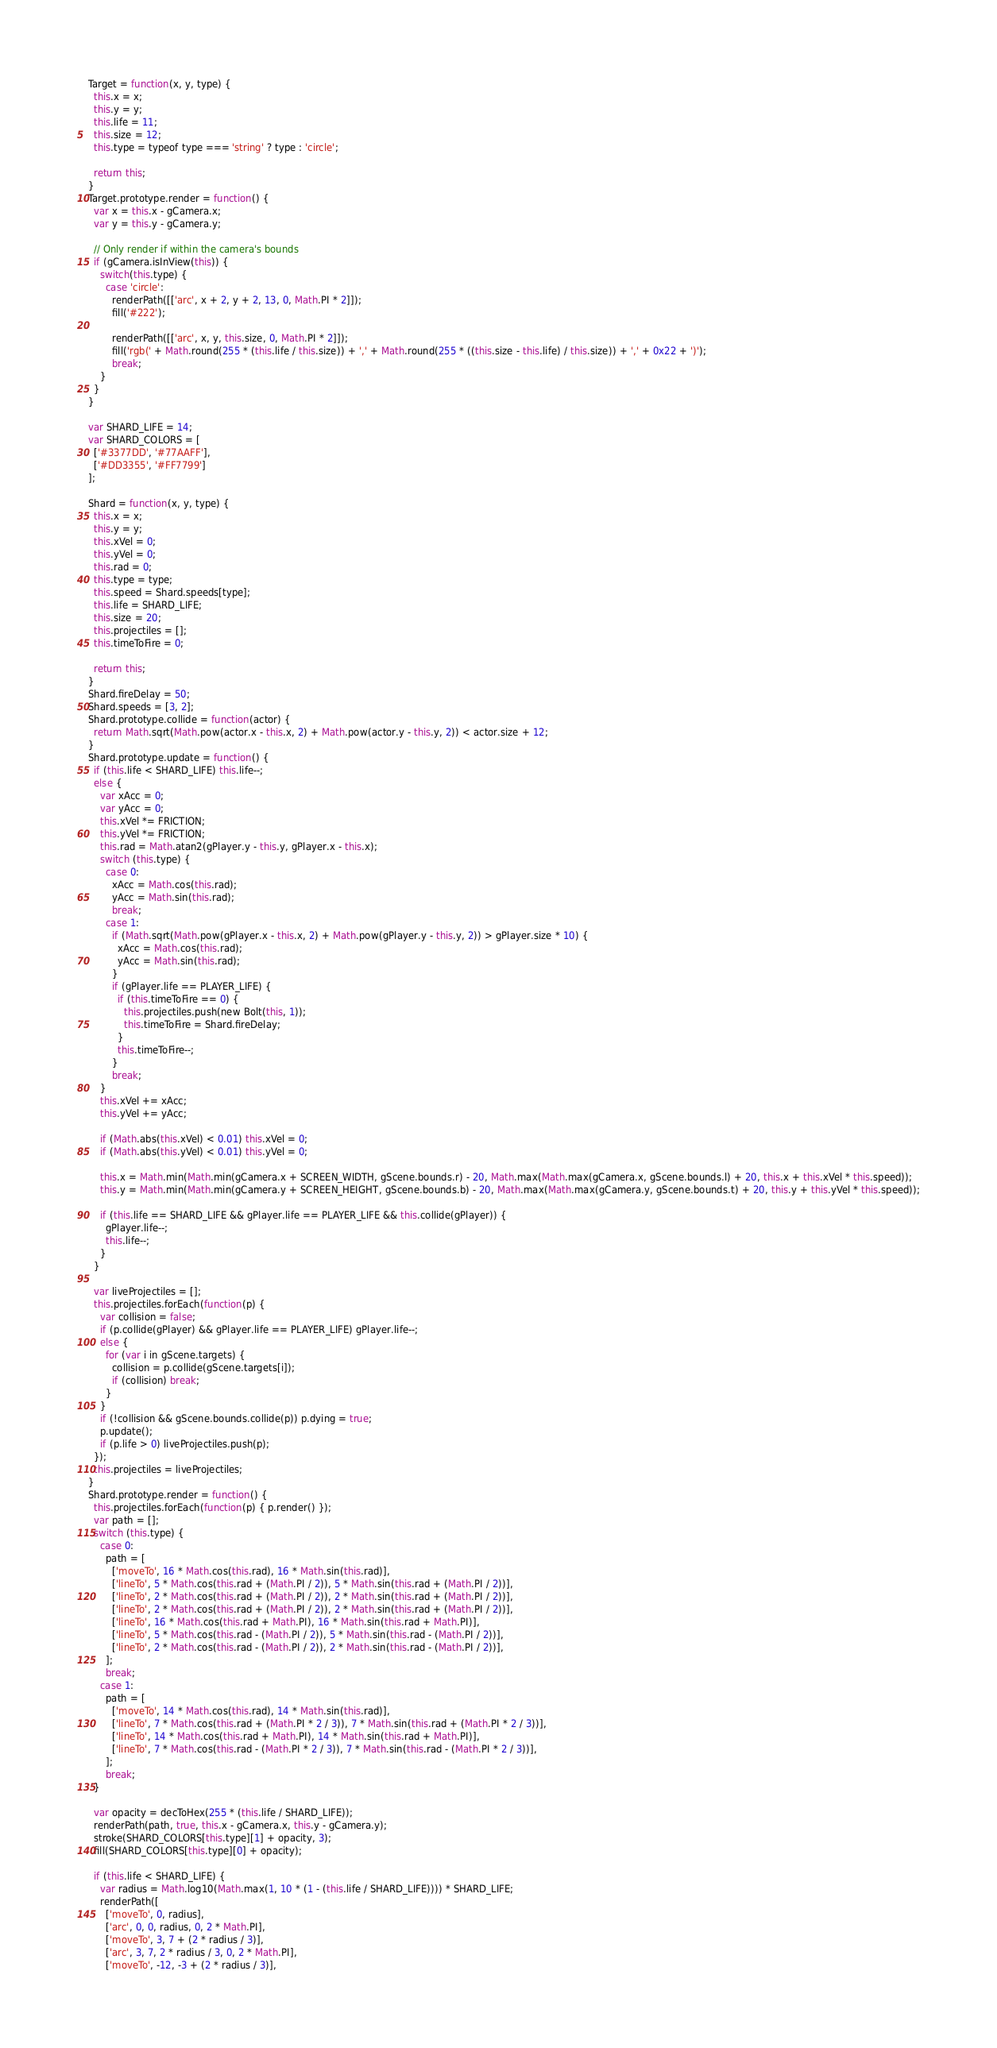<code> <loc_0><loc_0><loc_500><loc_500><_JavaScript_>Target = function(x, y, type) {
  this.x = x;
  this.y = y;
  this.life = 11;
  this.size = 12;
  this.type = typeof type === 'string' ? type : 'circle';

  return this;
}
Target.prototype.render = function() {
  var x = this.x - gCamera.x;
  var y = this.y - gCamera.y;

  // Only render if within the camera's bounds
  if (gCamera.isInView(this)) {
    switch(this.type) {
      case 'circle':
        renderPath([['arc', x + 2, y + 2, 13, 0, Math.PI * 2]]);
        fill('#222');

        renderPath([['arc', x, y, this.size, 0, Math.PI * 2]]);
        fill('rgb(' + Math.round(255 * (this.life / this.size)) + ',' + Math.round(255 * ((this.size - this.life) / this.size)) + ',' + 0x22 + ')');
        break;
    }
  }
}

var SHARD_LIFE = 14;
var SHARD_COLORS = [
  ['#3377DD', '#77AAFF'],
  ['#DD3355', '#FF7799']
];

Shard = function(x, y, type) {
  this.x = x;
  this.y = y;
  this.xVel = 0;
  this.yVel = 0;
  this.rad = 0;
  this.type = type;
  this.speed = Shard.speeds[type];
  this.life = SHARD_LIFE;
  this.size = 20;
  this.projectiles = [];
  this.timeToFire = 0;

  return this;
}
Shard.fireDelay = 50;
Shard.speeds = [3, 2];
Shard.prototype.collide = function(actor) {
  return Math.sqrt(Math.pow(actor.x - this.x, 2) + Math.pow(actor.y - this.y, 2)) < actor.size + 12;
}
Shard.prototype.update = function() {
  if (this.life < SHARD_LIFE) this.life--;
  else {
    var xAcc = 0;
    var yAcc = 0;
    this.xVel *= FRICTION;
    this.yVel *= FRICTION;
    this.rad = Math.atan2(gPlayer.y - this.y, gPlayer.x - this.x);
    switch (this.type) {
      case 0:
        xAcc = Math.cos(this.rad);
        yAcc = Math.sin(this.rad);
        break;
      case 1:
        if (Math.sqrt(Math.pow(gPlayer.x - this.x, 2) + Math.pow(gPlayer.y - this.y, 2)) > gPlayer.size * 10) {
          xAcc = Math.cos(this.rad);
          yAcc = Math.sin(this.rad);
        }
        if (gPlayer.life == PLAYER_LIFE) {
          if (this.timeToFire == 0) {
            this.projectiles.push(new Bolt(this, 1));
            this.timeToFire = Shard.fireDelay;
          }
          this.timeToFire--;
        }
        break;
    }
    this.xVel += xAcc;
    this.yVel += yAcc;

    if (Math.abs(this.xVel) < 0.01) this.xVel = 0;
    if (Math.abs(this.yVel) < 0.01) this.yVel = 0;

    this.x = Math.min(Math.min(gCamera.x + SCREEN_WIDTH, gScene.bounds.r) - 20, Math.max(Math.max(gCamera.x, gScene.bounds.l) + 20, this.x + this.xVel * this.speed));
    this.y = Math.min(Math.min(gCamera.y + SCREEN_HEIGHT, gScene.bounds.b) - 20, Math.max(Math.max(gCamera.y, gScene.bounds.t) + 20, this.y + this.yVel * this.speed));

    if (this.life == SHARD_LIFE && gPlayer.life == PLAYER_LIFE && this.collide(gPlayer)) {
      gPlayer.life--;
      this.life--;
    }
  }

  var liveProjectiles = [];
  this.projectiles.forEach(function(p) {
    var collision = false;
    if (p.collide(gPlayer) && gPlayer.life == PLAYER_LIFE) gPlayer.life--;
    else {
      for (var i in gScene.targets) {
        collision = p.collide(gScene.targets[i]);
        if (collision) break;
      }
    }
    if (!collision && gScene.bounds.collide(p)) p.dying = true;
    p.update();
    if (p.life > 0) liveProjectiles.push(p);
  });
  this.projectiles = liveProjectiles;
}
Shard.prototype.render = function() {
  this.projectiles.forEach(function(p) { p.render() });
  var path = [];
  switch (this.type) {
    case 0:
      path = [
        ['moveTo', 16 * Math.cos(this.rad), 16 * Math.sin(this.rad)],
        ['lineTo', 5 * Math.cos(this.rad + (Math.PI / 2)), 5 * Math.sin(this.rad + (Math.PI / 2))],
        ['lineTo', 2 * Math.cos(this.rad + (Math.PI / 2)), 2 * Math.sin(this.rad + (Math.PI / 2))],
        ['lineTo', 2 * Math.cos(this.rad + (Math.PI / 2)), 2 * Math.sin(this.rad + (Math.PI / 2))],
        ['lineTo', 16 * Math.cos(this.rad + Math.PI), 16 * Math.sin(this.rad + Math.PI)],
        ['lineTo', 5 * Math.cos(this.rad - (Math.PI / 2)), 5 * Math.sin(this.rad - (Math.PI / 2))],
        ['lineTo', 2 * Math.cos(this.rad - (Math.PI / 2)), 2 * Math.sin(this.rad - (Math.PI / 2))],
      ];
      break;
    case 1:
      path = [
        ['moveTo', 14 * Math.cos(this.rad), 14 * Math.sin(this.rad)],
        ['lineTo', 7 * Math.cos(this.rad + (Math.PI * 2 / 3)), 7 * Math.sin(this.rad + (Math.PI * 2 / 3))],
        ['lineTo', 14 * Math.cos(this.rad + Math.PI), 14 * Math.sin(this.rad + Math.PI)],
        ['lineTo', 7 * Math.cos(this.rad - (Math.PI * 2 / 3)), 7 * Math.sin(this.rad - (Math.PI * 2 / 3))],
      ];
      break;
  }

  var opacity = decToHex(255 * (this.life / SHARD_LIFE));
  renderPath(path, true, this.x - gCamera.x, this.y - gCamera.y);
  stroke(SHARD_COLORS[this.type][1] + opacity, 3);
  fill(SHARD_COLORS[this.type][0] + opacity);

  if (this.life < SHARD_LIFE) {
    var radius = Math.log10(Math.max(1, 10 * (1 - (this.life / SHARD_LIFE)))) * SHARD_LIFE;
    renderPath([
      ['moveTo', 0, radius],
      ['arc', 0, 0, radius, 0, 2 * Math.PI],
      ['moveTo', 3, 7 + (2 * radius / 3)],
      ['arc', 3, 7, 2 * radius / 3, 0, 2 * Math.PI],
      ['moveTo', -12, -3 + (2 * radius / 3)],</code> 